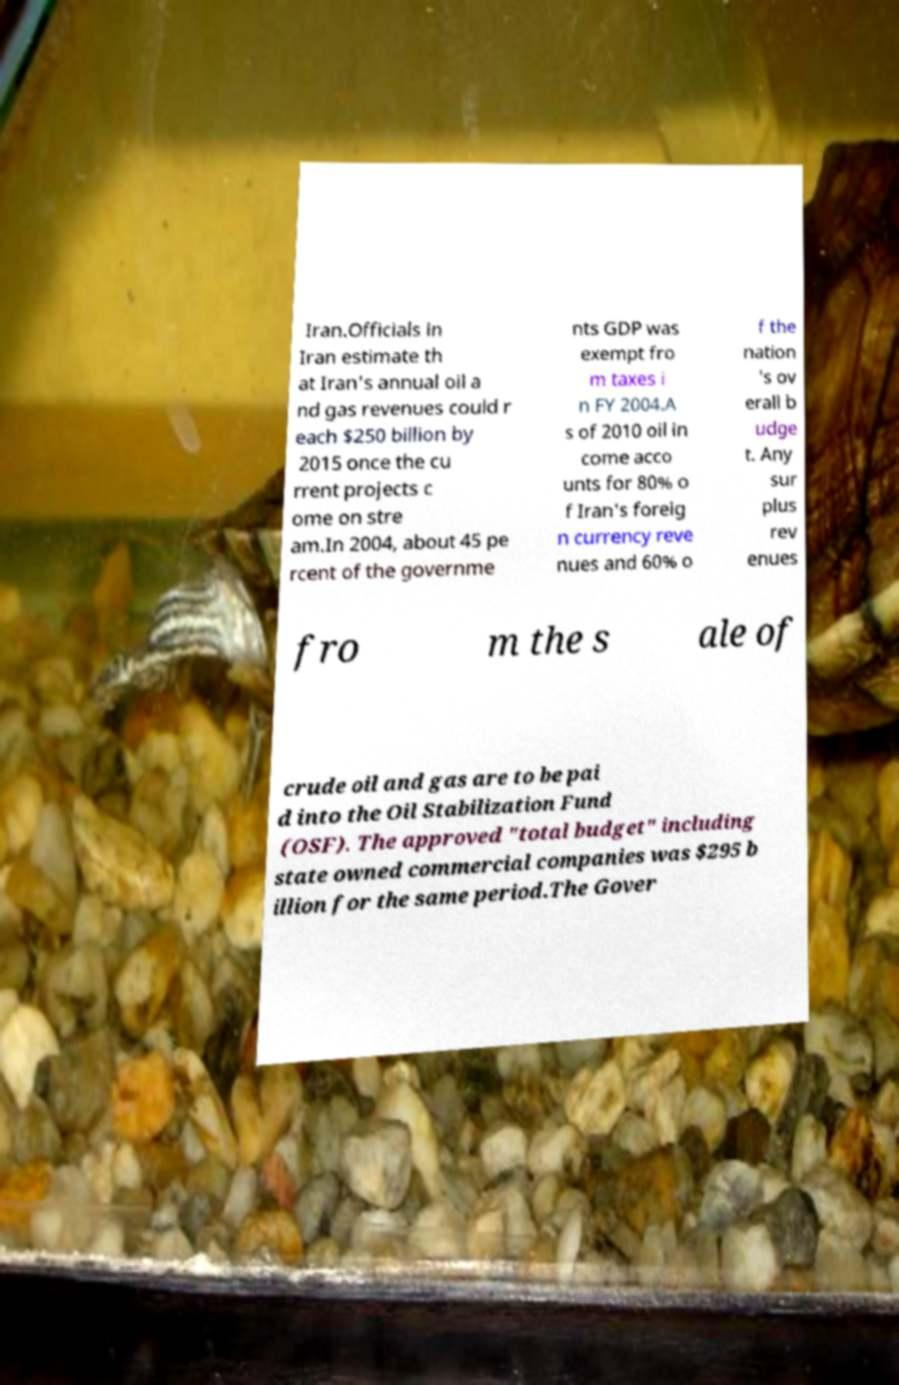Could you extract and type out the text from this image? Iran.Officials in Iran estimate th at Iran's annual oil a nd gas revenues could r each $250 billion by 2015 once the cu rrent projects c ome on stre am.In 2004, about 45 pe rcent of the governme nts GDP was exempt fro m taxes i n FY 2004.A s of 2010 oil in come acco unts for 80% o f Iran's foreig n currency reve nues and 60% o f the nation 's ov erall b udge t. Any sur plus rev enues fro m the s ale of crude oil and gas are to be pai d into the Oil Stabilization Fund (OSF). The approved "total budget" including state owned commercial companies was $295 b illion for the same period.The Gover 